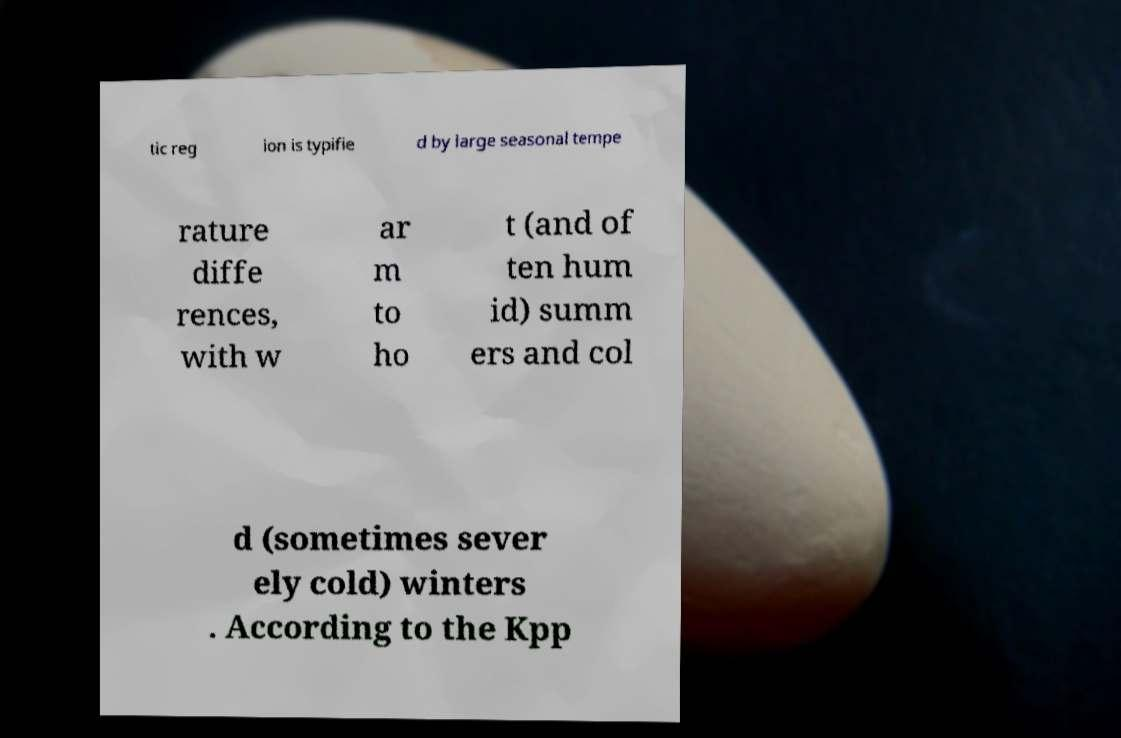There's text embedded in this image that I need extracted. Can you transcribe it verbatim? tic reg ion is typifie d by large seasonal tempe rature diffe rences, with w ar m to ho t (and of ten hum id) summ ers and col d (sometimes sever ely cold) winters . According to the Kpp 